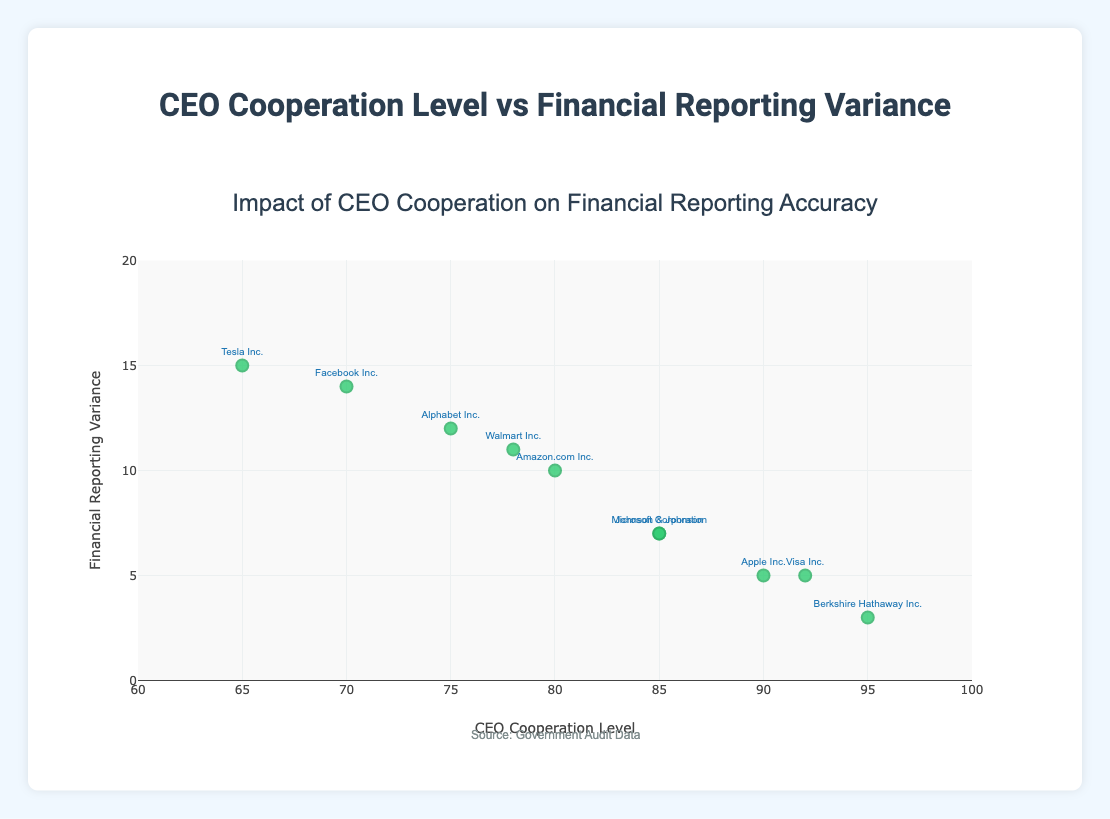What's the title of the figure? The title is found at the top of the plot, which gives an overview of the plot's subject matter. It reads "Impact of CEO Cooperation on Financial Reporting Accuracy"
Answer: Impact of CEO Cooperation on Financial Reporting Accuracy Which company has the lowest financial reporting variance? You can find the company with the lowest value by looking at the y-axis and locating the smallest number. The company with the lowest vertical position is Berkshire Hathaway Inc.
Answer: Berkshire Hathaway Inc How many data points are plotted? Each marker represents a data point from the given dataset. Counting all the markers, you will find there are 10 data points.
Answer: 10 What is the relationship between CEO cooperation level and financial reporting variance in the plot? Observing the plot, as the CEO cooperation level (x-axis) increases, the financial reporting variance (y-axis) tends to decrease, indicating an inverse relationship.
Answer: Inverse relationship What is the highest financial reporting variance observed and which company does it belong to? The highest financial reporting variance can be determined by the highest position on the y-axis. The plot shows that Tesla Inc. has the highest variance at 15.
Answer: 15, Tesla Inc Which company has the closest CEO cooperation level to 75 and what is its financial reporting variance? Match the company label closest to an x-axis value of 75. The company is Alphabet Inc., and its variance on the y-axis is 12.
Answer: Alphabet Inc., 12 Compare the financial reporting variance of Apple Inc. and Visa Inc. Locate the markers of both companies on the plot based on their cooperation levels. Both Apple Inc. and Visa Inc. have the same financial reporting variance of 5.
Answer: Both have a variance of 5 What is the average financial reporting variance of companies with a CEO cooperation level above 85? Identify companies with cooperation levels of 90, 95, 85, and 92 (Apple Inc., Berkshire Hathaway Inc., Microsoft Corporation, Johnson & Johnson, Visa Inc.). Their variances are 5, 3, 7, 7, and 5, respectively. The average is calculated as (5 + 3 + 7 + 7 + 5) / 5 = 5.4.
Answer: 5.4 Which company with a CEO cooperation level below 80 has the greatest financial reporting variance? Locate companies with cooperation levels below 80: Amazon.com Inc., Alphabet Inc., Tesla Inc., Facebook Inc., Walmart Inc.. Comparing their variances (10, 12, 15, 14, 11), the greatest is for Tesla Inc. with 15.
Answer: Tesla Inc Is there any company with a financial reporting variance exactly equal to 10? If so, which company? Look along the y-axis for exactly 10 and trace it to the company label. Amazon.com Inc. has a financial reporting variance of 10.
Answer: Amazon.com Inc 